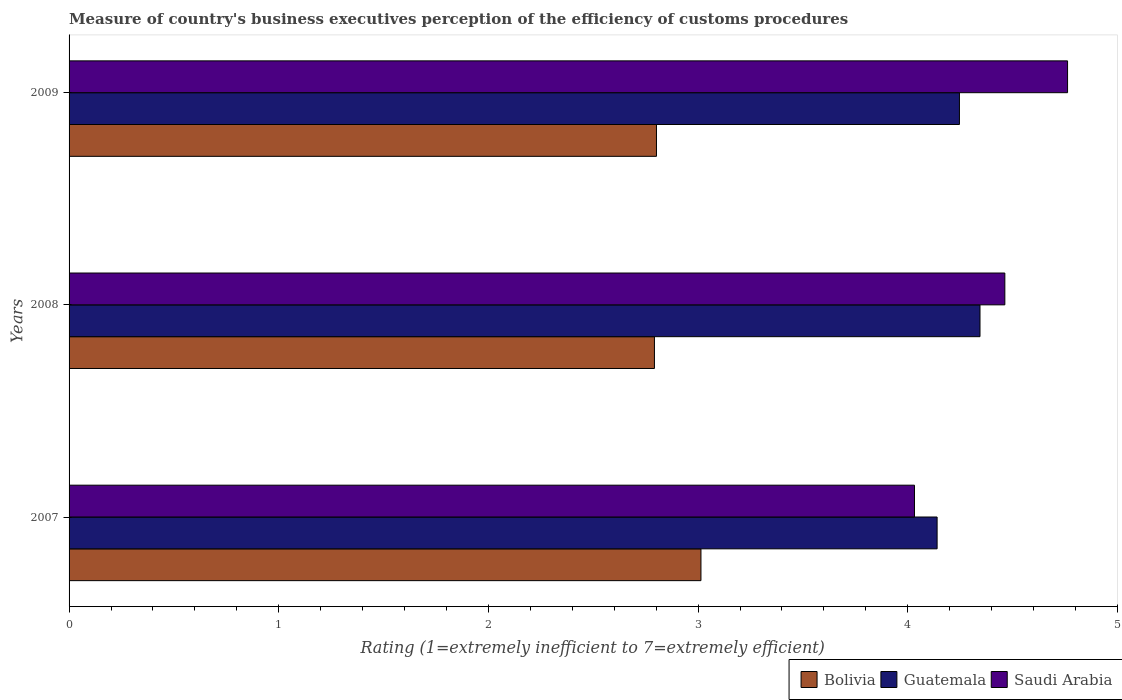How many bars are there on the 3rd tick from the top?
Your answer should be very brief. 3. What is the label of the 1st group of bars from the top?
Keep it short and to the point. 2009. What is the rating of the efficiency of customs procedure in Saudi Arabia in 2008?
Make the answer very short. 4.46. Across all years, what is the maximum rating of the efficiency of customs procedure in Guatemala?
Your answer should be compact. 4.34. Across all years, what is the minimum rating of the efficiency of customs procedure in Guatemala?
Make the answer very short. 4.14. What is the total rating of the efficiency of customs procedure in Saudi Arabia in the graph?
Provide a succinct answer. 13.26. What is the difference between the rating of the efficiency of customs procedure in Saudi Arabia in 2007 and that in 2008?
Provide a short and direct response. -0.43. What is the difference between the rating of the efficiency of customs procedure in Bolivia in 2009 and the rating of the efficiency of customs procedure in Guatemala in 2008?
Your answer should be compact. -1.54. What is the average rating of the efficiency of customs procedure in Bolivia per year?
Your answer should be very brief. 2.87. In the year 2008, what is the difference between the rating of the efficiency of customs procedure in Guatemala and rating of the efficiency of customs procedure in Saudi Arabia?
Your response must be concise. -0.12. What is the ratio of the rating of the efficiency of customs procedure in Saudi Arabia in 2007 to that in 2009?
Keep it short and to the point. 0.85. Is the difference between the rating of the efficiency of customs procedure in Guatemala in 2007 and 2009 greater than the difference between the rating of the efficiency of customs procedure in Saudi Arabia in 2007 and 2009?
Your response must be concise. Yes. What is the difference between the highest and the second highest rating of the efficiency of customs procedure in Guatemala?
Offer a very short reply. 0.1. What is the difference between the highest and the lowest rating of the efficiency of customs procedure in Bolivia?
Your answer should be very brief. 0.22. In how many years, is the rating of the efficiency of customs procedure in Guatemala greater than the average rating of the efficiency of customs procedure in Guatemala taken over all years?
Ensure brevity in your answer.  2. What does the 1st bar from the top in 2007 represents?
Make the answer very short. Saudi Arabia. What does the 2nd bar from the bottom in 2007 represents?
Give a very brief answer. Guatemala. Is it the case that in every year, the sum of the rating of the efficiency of customs procedure in Saudi Arabia and rating of the efficiency of customs procedure in Bolivia is greater than the rating of the efficiency of customs procedure in Guatemala?
Your answer should be compact. Yes. How many bars are there?
Your answer should be compact. 9. What is the difference between two consecutive major ticks on the X-axis?
Offer a very short reply. 1. Does the graph contain any zero values?
Your response must be concise. No. Does the graph contain grids?
Keep it short and to the point. No. Where does the legend appear in the graph?
Your answer should be compact. Bottom right. What is the title of the graph?
Keep it short and to the point. Measure of country's business executives perception of the efficiency of customs procedures. What is the label or title of the X-axis?
Keep it short and to the point. Rating (1=extremely inefficient to 7=extremely efficient). What is the Rating (1=extremely inefficient to 7=extremely efficient) in Bolivia in 2007?
Give a very brief answer. 3.01. What is the Rating (1=extremely inefficient to 7=extremely efficient) in Guatemala in 2007?
Keep it short and to the point. 4.14. What is the Rating (1=extremely inefficient to 7=extremely efficient) of Saudi Arabia in 2007?
Offer a terse response. 4.03. What is the Rating (1=extremely inefficient to 7=extremely efficient) of Bolivia in 2008?
Provide a short and direct response. 2.79. What is the Rating (1=extremely inefficient to 7=extremely efficient) in Guatemala in 2008?
Offer a very short reply. 4.34. What is the Rating (1=extremely inefficient to 7=extremely efficient) of Saudi Arabia in 2008?
Make the answer very short. 4.46. What is the Rating (1=extremely inefficient to 7=extremely efficient) in Bolivia in 2009?
Offer a terse response. 2.8. What is the Rating (1=extremely inefficient to 7=extremely efficient) of Guatemala in 2009?
Provide a succinct answer. 4.25. What is the Rating (1=extremely inefficient to 7=extremely efficient) in Saudi Arabia in 2009?
Give a very brief answer. 4.76. Across all years, what is the maximum Rating (1=extremely inefficient to 7=extremely efficient) in Bolivia?
Ensure brevity in your answer.  3.01. Across all years, what is the maximum Rating (1=extremely inefficient to 7=extremely efficient) in Guatemala?
Your answer should be compact. 4.34. Across all years, what is the maximum Rating (1=extremely inefficient to 7=extremely efficient) in Saudi Arabia?
Your answer should be very brief. 4.76. Across all years, what is the minimum Rating (1=extremely inefficient to 7=extremely efficient) in Bolivia?
Offer a terse response. 2.79. Across all years, what is the minimum Rating (1=extremely inefficient to 7=extremely efficient) of Guatemala?
Your response must be concise. 4.14. Across all years, what is the minimum Rating (1=extremely inefficient to 7=extremely efficient) of Saudi Arabia?
Provide a short and direct response. 4.03. What is the total Rating (1=extremely inefficient to 7=extremely efficient) of Bolivia in the graph?
Offer a terse response. 8.61. What is the total Rating (1=extremely inefficient to 7=extremely efficient) in Guatemala in the graph?
Your response must be concise. 12.73. What is the total Rating (1=extremely inefficient to 7=extremely efficient) of Saudi Arabia in the graph?
Give a very brief answer. 13.26. What is the difference between the Rating (1=extremely inefficient to 7=extremely efficient) in Bolivia in 2007 and that in 2008?
Keep it short and to the point. 0.22. What is the difference between the Rating (1=extremely inefficient to 7=extremely efficient) of Guatemala in 2007 and that in 2008?
Provide a succinct answer. -0.2. What is the difference between the Rating (1=extremely inefficient to 7=extremely efficient) of Saudi Arabia in 2007 and that in 2008?
Keep it short and to the point. -0.43. What is the difference between the Rating (1=extremely inefficient to 7=extremely efficient) in Bolivia in 2007 and that in 2009?
Give a very brief answer. 0.21. What is the difference between the Rating (1=extremely inefficient to 7=extremely efficient) in Guatemala in 2007 and that in 2009?
Offer a terse response. -0.11. What is the difference between the Rating (1=extremely inefficient to 7=extremely efficient) in Saudi Arabia in 2007 and that in 2009?
Provide a succinct answer. -0.73. What is the difference between the Rating (1=extremely inefficient to 7=extremely efficient) in Bolivia in 2008 and that in 2009?
Provide a short and direct response. -0.01. What is the difference between the Rating (1=extremely inefficient to 7=extremely efficient) in Guatemala in 2008 and that in 2009?
Provide a short and direct response. 0.1. What is the difference between the Rating (1=extremely inefficient to 7=extremely efficient) in Saudi Arabia in 2008 and that in 2009?
Your response must be concise. -0.3. What is the difference between the Rating (1=extremely inefficient to 7=extremely efficient) of Bolivia in 2007 and the Rating (1=extremely inefficient to 7=extremely efficient) of Guatemala in 2008?
Ensure brevity in your answer.  -1.33. What is the difference between the Rating (1=extremely inefficient to 7=extremely efficient) in Bolivia in 2007 and the Rating (1=extremely inefficient to 7=extremely efficient) in Saudi Arabia in 2008?
Your answer should be very brief. -1.45. What is the difference between the Rating (1=extremely inefficient to 7=extremely efficient) of Guatemala in 2007 and the Rating (1=extremely inefficient to 7=extremely efficient) of Saudi Arabia in 2008?
Your response must be concise. -0.32. What is the difference between the Rating (1=extremely inefficient to 7=extremely efficient) of Bolivia in 2007 and the Rating (1=extremely inefficient to 7=extremely efficient) of Guatemala in 2009?
Keep it short and to the point. -1.23. What is the difference between the Rating (1=extremely inefficient to 7=extremely efficient) in Bolivia in 2007 and the Rating (1=extremely inefficient to 7=extremely efficient) in Saudi Arabia in 2009?
Keep it short and to the point. -1.75. What is the difference between the Rating (1=extremely inefficient to 7=extremely efficient) in Guatemala in 2007 and the Rating (1=extremely inefficient to 7=extremely efficient) in Saudi Arabia in 2009?
Your answer should be very brief. -0.62. What is the difference between the Rating (1=extremely inefficient to 7=extremely efficient) in Bolivia in 2008 and the Rating (1=extremely inefficient to 7=extremely efficient) in Guatemala in 2009?
Your response must be concise. -1.45. What is the difference between the Rating (1=extremely inefficient to 7=extremely efficient) of Bolivia in 2008 and the Rating (1=extremely inefficient to 7=extremely efficient) of Saudi Arabia in 2009?
Provide a succinct answer. -1.97. What is the difference between the Rating (1=extremely inefficient to 7=extremely efficient) of Guatemala in 2008 and the Rating (1=extremely inefficient to 7=extremely efficient) of Saudi Arabia in 2009?
Offer a very short reply. -0.42. What is the average Rating (1=extremely inefficient to 7=extremely efficient) in Bolivia per year?
Your answer should be compact. 2.87. What is the average Rating (1=extremely inefficient to 7=extremely efficient) in Guatemala per year?
Give a very brief answer. 4.24. What is the average Rating (1=extremely inefficient to 7=extremely efficient) of Saudi Arabia per year?
Ensure brevity in your answer.  4.42. In the year 2007, what is the difference between the Rating (1=extremely inefficient to 7=extremely efficient) in Bolivia and Rating (1=extremely inefficient to 7=extremely efficient) in Guatemala?
Give a very brief answer. -1.13. In the year 2007, what is the difference between the Rating (1=extremely inefficient to 7=extremely efficient) of Bolivia and Rating (1=extremely inefficient to 7=extremely efficient) of Saudi Arabia?
Give a very brief answer. -1.02. In the year 2007, what is the difference between the Rating (1=extremely inefficient to 7=extremely efficient) in Guatemala and Rating (1=extremely inefficient to 7=extremely efficient) in Saudi Arabia?
Offer a very short reply. 0.11. In the year 2008, what is the difference between the Rating (1=extremely inefficient to 7=extremely efficient) in Bolivia and Rating (1=extremely inefficient to 7=extremely efficient) in Guatemala?
Provide a succinct answer. -1.55. In the year 2008, what is the difference between the Rating (1=extremely inefficient to 7=extremely efficient) in Bolivia and Rating (1=extremely inefficient to 7=extremely efficient) in Saudi Arabia?
Offer a very short reply. -1.67. In the year 2008, what is the difference between the Rating (1=extremely inefficient to 7=extremely efficient) in Guatemala and Rating (1=extremely inefficient to 7=extremely efficient) in Saudi Arabia?
Make the answer very short. -0.12. In the year 2009, what is the difference between the Rating (1=extremely inefficient to 7=extremely efficient) of Bolivia and Rating (1=extremely inefficient to 7=extremely efficient) of Guatemala?
Provide a succinct answer. -1.45. In the year 2009, what is the difference between the Rating (1=extremely inefficient to 7=extremely efficient) of Bolivia and Rating (1=extremely inefficient to 7=extremely efficient) of Saudi Arabia?
Keep it short and to the point. -1.96. In the year 2009, what is the difference between the Rating (1=extremely inefficient to 7=extremely efficient) of Guatemala and Rating (1=extremely inefficient to 7=extremely efficient) of Saudi Arabia?
Give a very brief answer. -0.52. What is the ratio of the Rating (1=extremely inefficient to 7=extremely efficient) in Bolivia in 2007 to that in 2008?
Provide a succinct answer. 1.08. What is the ratio of the Rating (1=extremely inefficient to 7=extremely efficient) of Guatemala in 2007 to that in 2008?
Your response must be concise. 0.95. What is the ratio of the Rating (1=extremely inefficient to 7=extremely efficient) of Saudi Arabia in 2007 to that in 2008?
Give a very brief answer. 0.9. What is the ratio of the Rating (1=extremely inefficient to 7=extremely efficient) of Bolivia in 2007 to that in 2009?
Your answer should be compact. 1.08. What is the ratio of the Rating (1=extremely inefficient to 7=extremely efficient) of Guatemala in 2007 to that in 2009?
Your answer should be very brief. 0.97. What is the ratio of the Rating (1=extremely inefficient to 7=extremely efficient) in Saudi Arabia in 2007 to that in 2009?
Provide a short and direct response. 0.85. What is the ratio of the Rating (1=extremely inefficient to 7=extremely efficient) of Bolivia in 2008 to that in 2009?
Offer a terse response. 1. What is the ratio of the Rating (1=extremely inefficient to 7=extremely efficient) of Guatemala in 2008 to that in 2009?
Provide a short and direct response. 1.02. What is the ratio of the Rating (1=extremely inefficient to 7=extremely efficient) in Saudi Arabia in 2008 to that in 2009?
Ensure brevity in your answer.  0.94. What is the difference between the highest and the second highest Rating (1=extremely inefficient to 7=extremely efficient) of Bolivia?
Your response must be concise. 0.21. What is the difference between the highest and the second highest Rating (1=extremely inefficient to 7=extremely efficient) in Guatemala?
Keep it short and to the point. 0.1. What is the difference between the highest and the second highest Rating (1=extremely inefficient to 7=extremely efficient) of Saudi Arabia?
Give a very brief answer. 0.3. What is the difference between the highest and the lowest Rating (1=extremely inefficient to 7=extremely efficient) of Bolivia?
Make the answer very short. 0.22. What is the difference between the highest and the lowest Rating (1=extremely inefficient to 7=extremely efficient) in Guatemala?
Make the answer very short. 0.2. What is the difference between the highest and the lowest Rating (1=extremely inefficient to 7=extremely efficient) of Saudi Arabia?
Give a very brief answer. 0.73. 